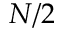<formula> <loc_0><loc_0><loc_500><loc_500>N / 2</formula> 